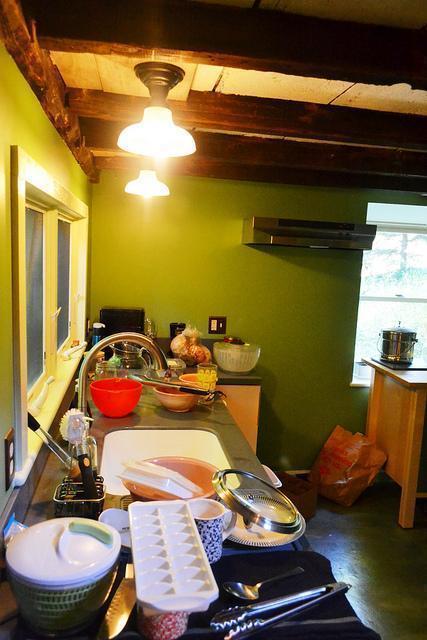What is the electrical device on the wall to the left of the window used for?
Select the correct answer and articulate reasoning with the following format: 'Answer: answer
Rationale: rationale.'
Options: Hvac, entertainment, lighting, storage. Answer: hvac.
Rationale: The bulb is used to give light. 